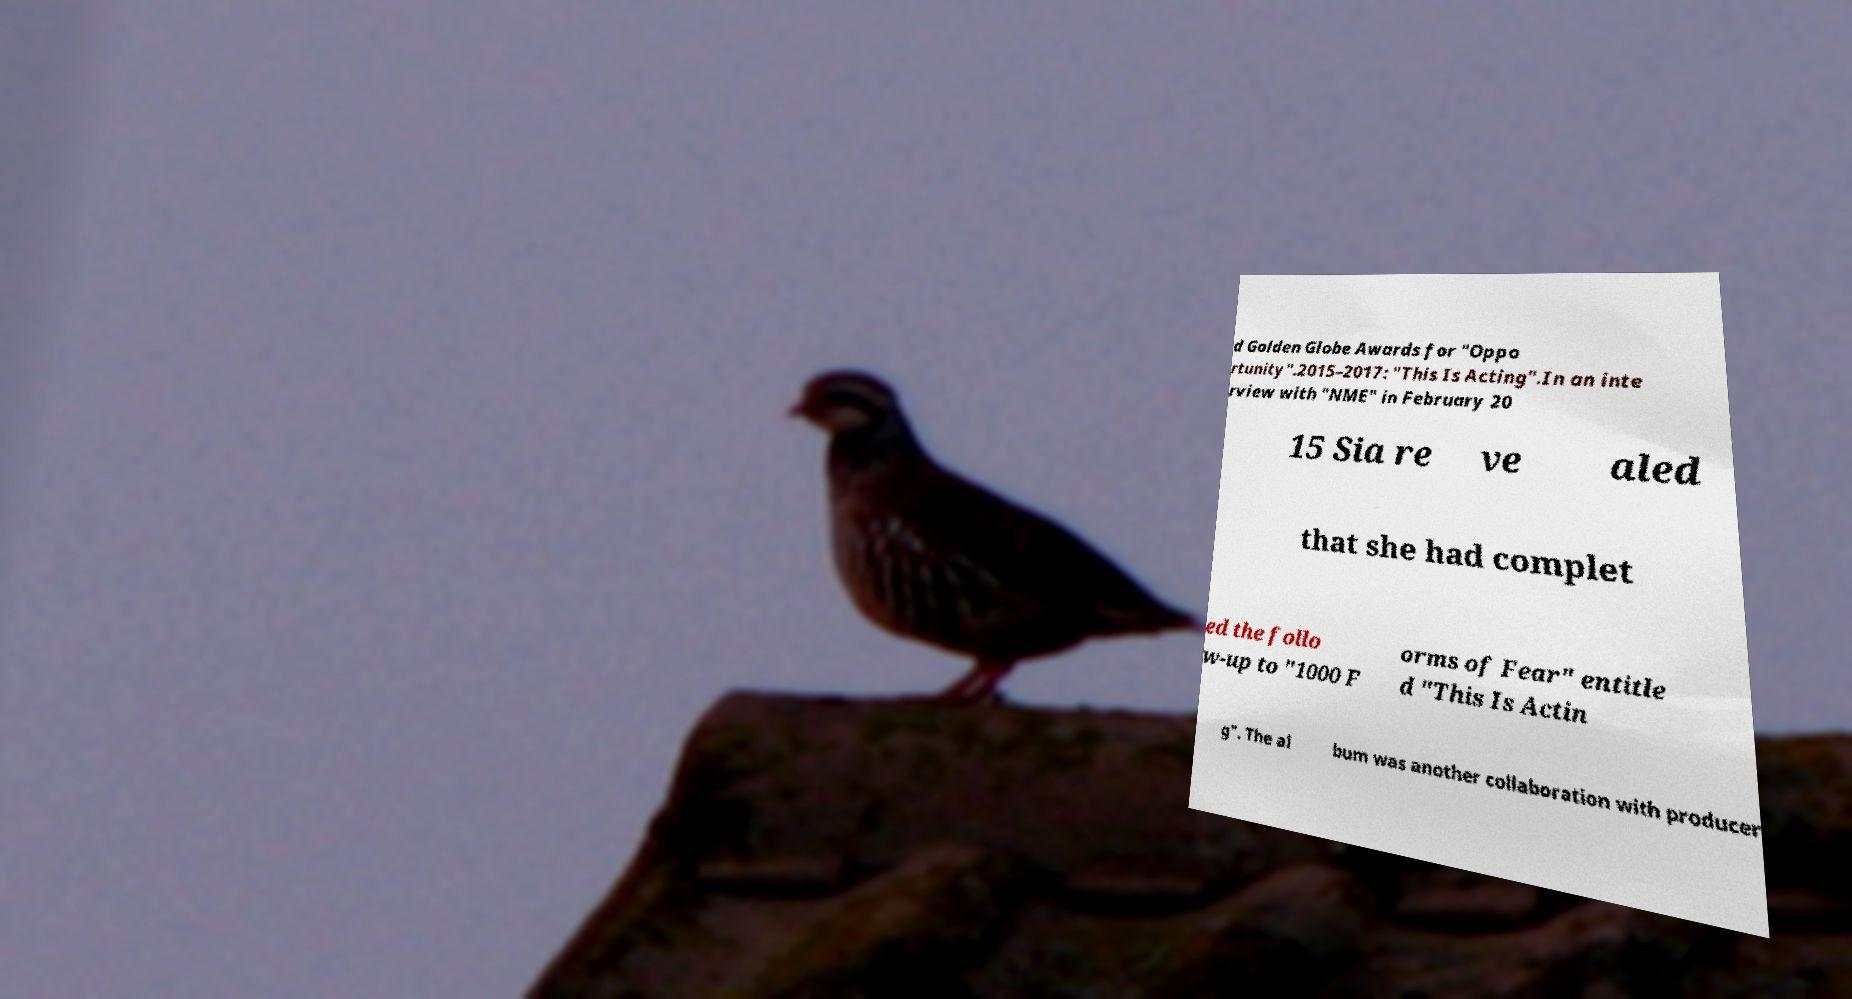There's text embedded in this image that I need extracted. Can you transcribe it verbatim? d Golden Globe Awards for "Oppo rtunity".2015–2017: "This Is Acting".In an inte rview with "NME" in February 20 15 Sia re ve aled that she had complet ed the follo w-up to "1000 F orms of Fear" entitle d "This Is Actin g". The al bum was another collaboration with producer 